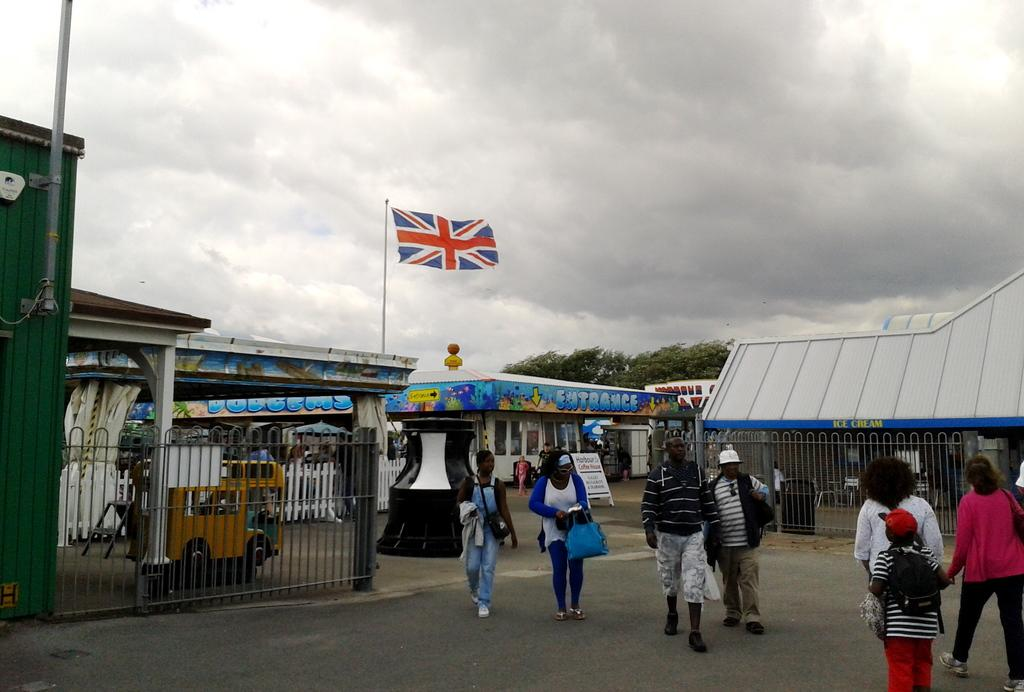<image>
Render a clear and concise summary of the photo. An entrance sign can be seen on the building near the flag. 